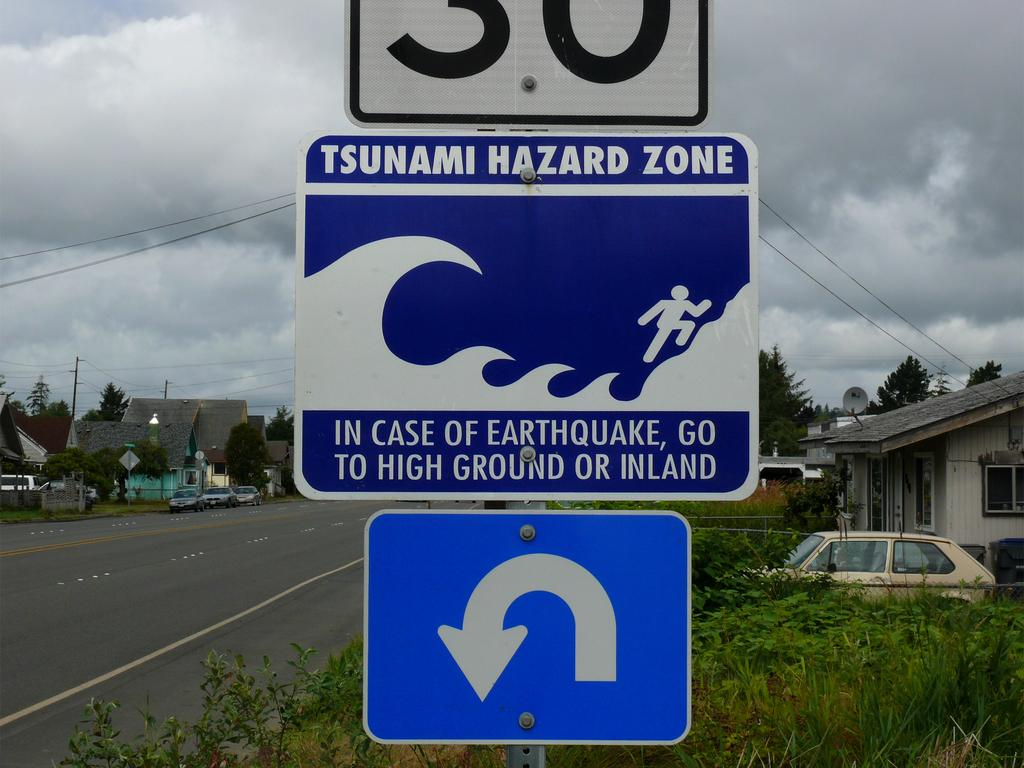<image>
Render a clear and concise summary of the photo. A blue street sign says Tsunami Hazard Zone and shows a person running from a wave. 